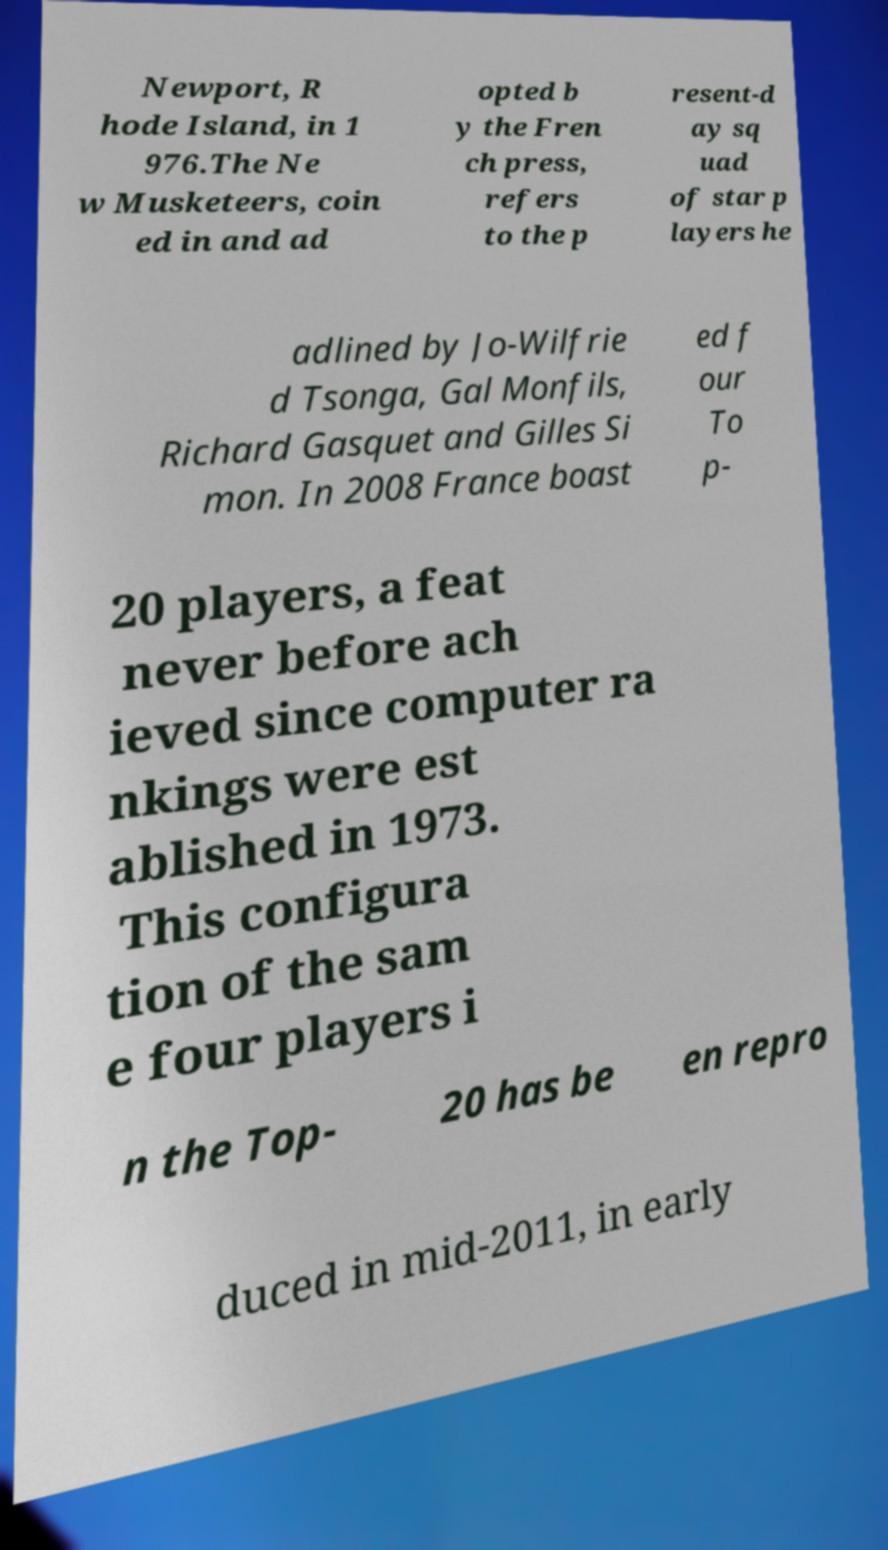Could you assist in decoding the text presented in this image and type it out clearly? Newport, R hode Island, in 1 976.The Ne w Musketeers, coin ed in and ad opted b y the Fren ch press, refers to the p resent-d ay sq uad of star p layers he adlined by Jo-Wilfrie d Tsonga, Gal Monfils, Richard Gasquet and Gilles Si mon. In 2008 France boast ed f our To p- 20 players, a feat never before ach ieved since computer ra nkings were est ablished in 1973. This configura tion of the sam e four players i n the Top- 20 has be en repro duced in mid-2011, in early 